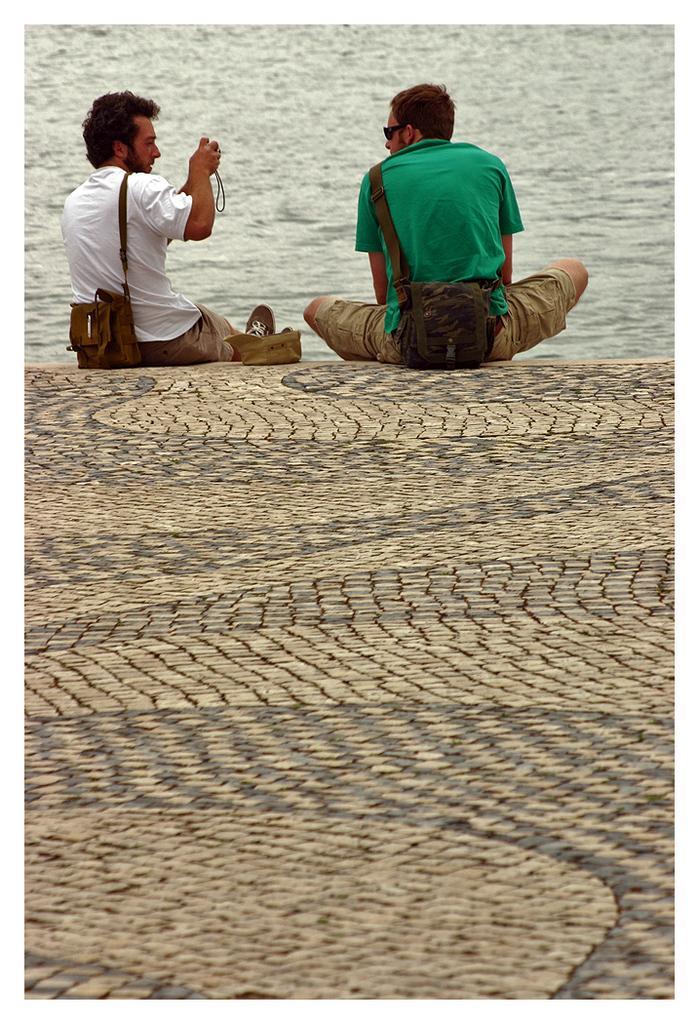Describe this image in one or two sentences. This image consists of two men sitting on the ground. In the background, there is water. 